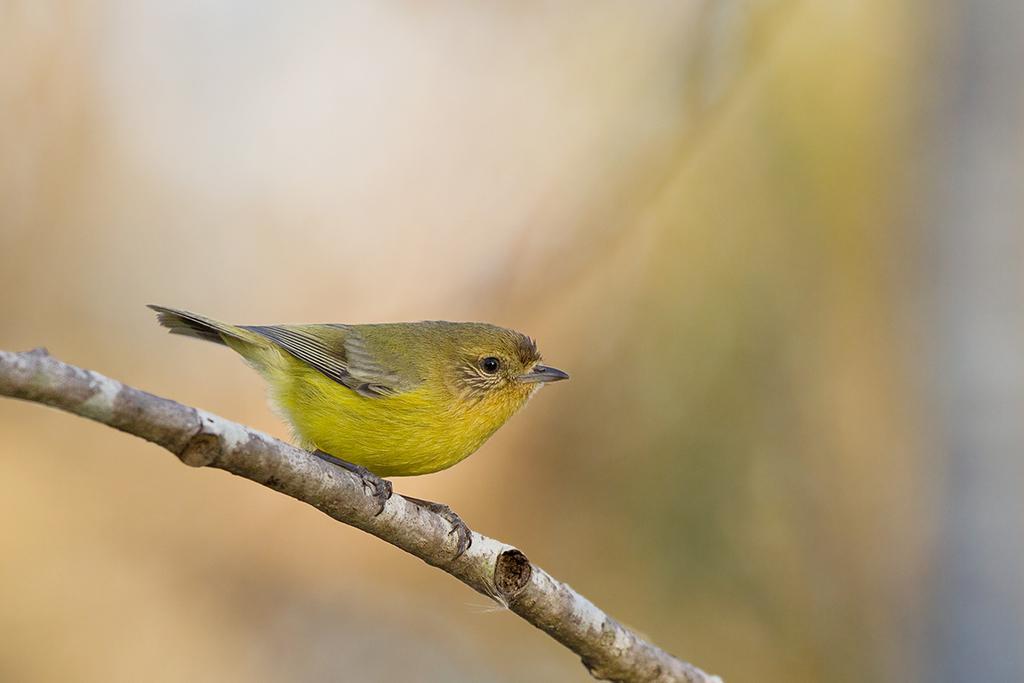Describe this image in one or two sentences. In the image there is a yellow color bird standing on branch behind it, it's all blur. 